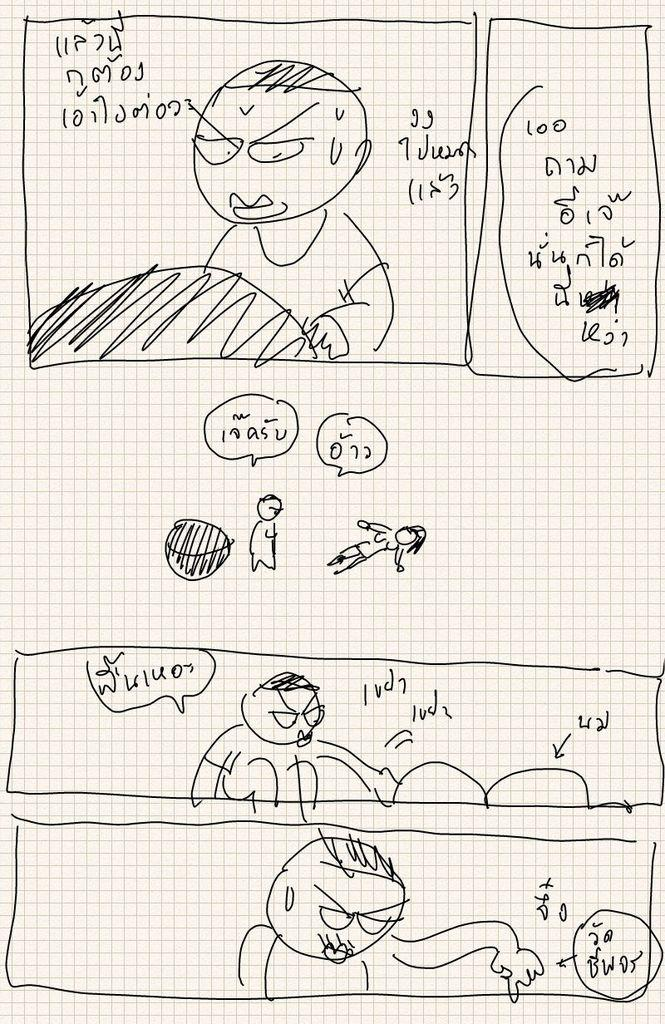What can be seen in the image? There are different types of sketches in the image. Are there any words or text in the image? Yes, there is writing on the top, center, and bottom side of the image. How many cows are present in the image? There are no cows present in the image; it features sketches and writing. 